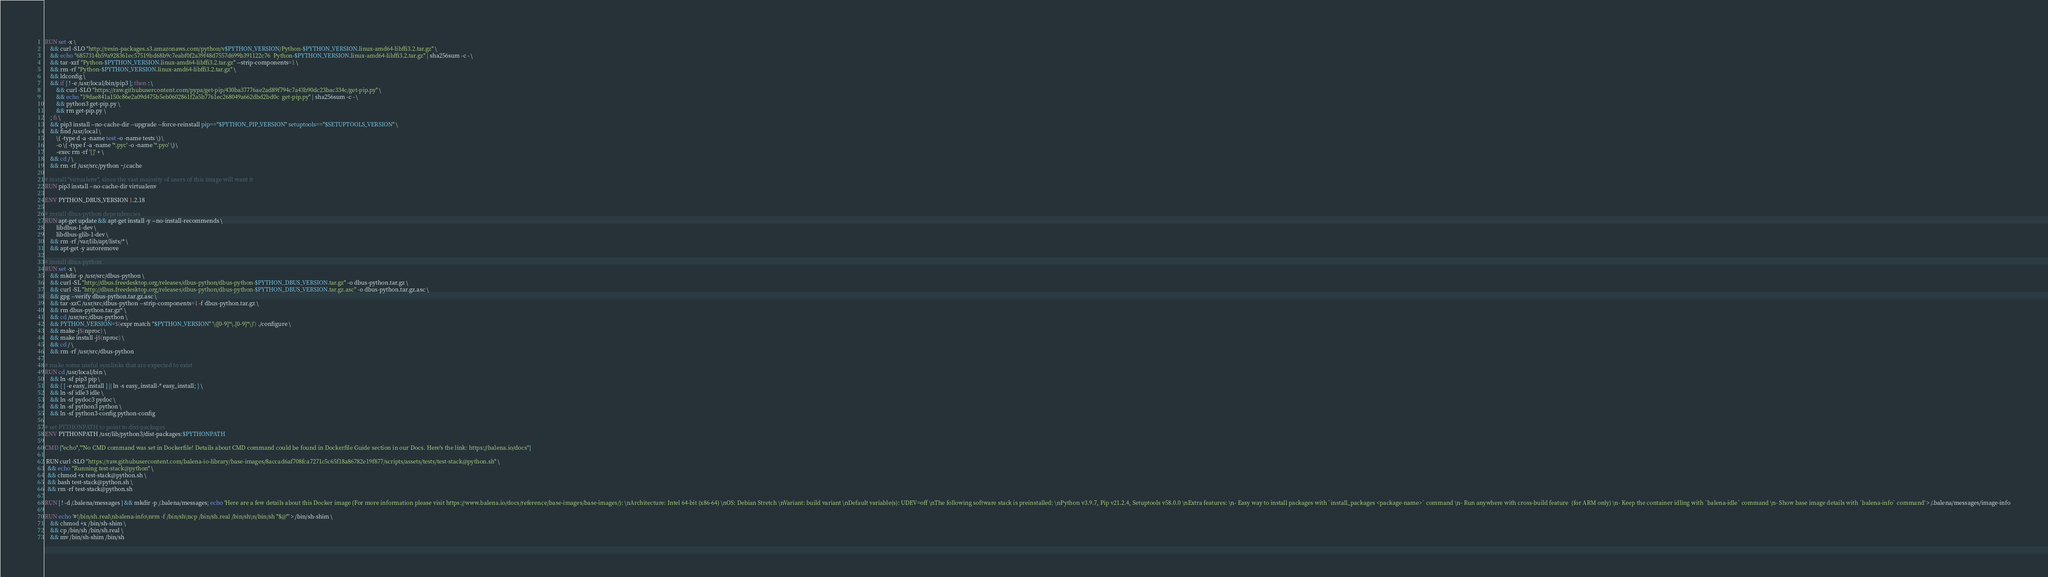Convert code to text. <code><loc_0><loc_0><loc_500><loc_500><_Dockerfile_>
RUN set -x \
	&& curl -SLO "http://resin-packages.s3.amazonaws.com/python/v$PYTHON_VERSION/Python-$PYTHON_VERSION.linux-amd64-libffi3.2.tar.gz" \
	&& echo "6857314b59a928361ec57519bd68b9c7eabf0f2a39f48d7557d699b391122c76  Python-$PYTHON_VERSION.linux-amd64-libffi3.2.tar.gz" | sha256sum -c - \
	&& tar -xzf "Python-$PYTHON_VERSION.linux-amd64-libffi3.2.tar.gz" --strip-components=1 \
	&& rm -rf "Python-$PYTHON_VERSION.linux-amd64-libffi3.2.tar.gz" \
	&& ldconfig \
	&& if [ ! -e /usr/local/bin/pip3 ]; then : \
		&& curl -SLO "https://raw.githubusercontent.com/pypa/get-pip/430ba37776ae2ad89f794c7a43b90dc23bac334c/get-pip.py" \
		&& echo "19dae841a150c86e2a09d475b5eb0602861f2a5b7761ec268049a662dbd2bd0c  get-pip.py" | sha256sum -c - \
		&& python3 get-pip.py \
		&& rm get-pip.py \
	; fi \
	&& pip3 install --no-cache-dir --upgrade --force-reinstall pip=="$PYTHON_PIP_VERSION" setuptools=="$SETUPTOOLS_VERSION" \
	&& find /usr/local \
		\( -type d -a -name test -o -name tests \) \
		-o \( -type f -a -name '*.pyc' -o -name '*.pyo' \) \
		-exec rm -rf '{}' + \
	&& cd / \
	&& rm -rf /usr/src/python ~/.cache

# install "virtualenv", since the vast majority of users of this image will want it
RUN pip3 install --no-cache-dir virtualenv

ENV PYTHON_DBUS_VERSION 1.2.18

# install dbus-python dependencies 
RUN apt-get update && apt-get install -y --no-install-recommends \
		libdbus-1-dev \
		libdbus-glib-1-dev \
	&& rm -rf /var/lib/apt/lists/* \
	&& apt-get -y autoremove

# install dbus-python
RUN set -x \
	&& mkdir -p /usr/src/dbus-python \
	&& curl -SL "http://dbus.freedesktop.org/releases/dbus-python/dbus-python-$PYTHON_DBUS_VERSION.tar.gz" -o dbus-python.tar.gz \
	&& curl -SL "http://dbus.freedesktop.org/releases/dbus-python/dbus-python-$PYTHON_DBUS_VERSION.tar.gz.asc" -o dbus-python.tar.gz.asc \
	&& gpg --verify dbus-python.tar.gz.asc \
	&& tar -xzC /usr/src/dbus-python --strip-components=1 -f dbus-python.tar.gz \
	&& rm dbus-python.tar.gz* \
	&& cd /usr/src/dbus-python \
	&& PYTHON_VERSION=$(expr match "$PYTHON_VERSION" '\([0-9]*\.[0-9]*\)') ./configure \
	&& make -j$(nproc) \
	&& make install -j$(nproc) \
	&& cd / \
	&& rm -rf /usr/src/dbus-python

# make some useful symlinks that are expected to exist
RUN cd /usr/local/bin \
	&& ln -sf pip3 pip \
	&& { [ -e easy_install ] || ln -s easy_install-* easy_install; } \
	&& ln -sf idle3 idle \
	&& ln -sf pydoc3 pydoc \
	&& ln -sf python3 python \
	&& ln -sf python3-config python-config

# set PYTHONPATH to point to dist-packages
ENV PYTHONPATH /usr/lib/python3/dist-packages:$PYTHONPATH

CMD ["echo","'No CMD command was set in Dockerfile! Details about CMD command could be found in Dockerfile Guide section in our Docs. Here's the link: https://balena.io/docs"]

 RUN curl -SLO "https://raw.githubusercontent.com/balena-io-library/base-images/8accad6af708fca7271c5c65f18a86782e19f877/scripts/assets/tests/test-stack@python.sh" \
  && echo "Running test-stack@python" \
  && chmod +x test-stack@python.sh \
  && bash test-stack@python.sh \
  && rm -rf test-stack@python.sh 

RUN [ ! -d /.balena/messages ] && mkdir -p /.balena/messages; echo 'Here are a few details about this Docker image (For more information please visit https://www.balena.io/docs/reference/base-images/base-images/): \nArchitecture: Intel 64-bit (x86-64) \nOS: Debian Stretch \nVariant: build variant \nDefault variable(s): UDEV=off \nThe following software stack is preinstalled: \nPython v3.9.7, Pip v21.2.4, Setuptools v58.0.0 \nExtra features: \n- Easy way to install packages with `install_packages <package-name>` command \n- Run anywhere with cross-build feature  (for ARM only) \n- Keep the container idling with `balena-idle` command \n- Show base image details with `balena-info` command' > /.balena/messages/image-info

RUN echo '#!/bin/sh.real\nbalena-info\nrm -f /bin/sh\ncp /bin/sh.real /bin/sh\n/bin/sh "$@"' > /bin/sh-shim \
	&& chmod +x /bin/sh-shim \
	&& cp /bin/sh /bin/sh.real \
	&& mv /bin/sh-shim /bin/sh</code> 